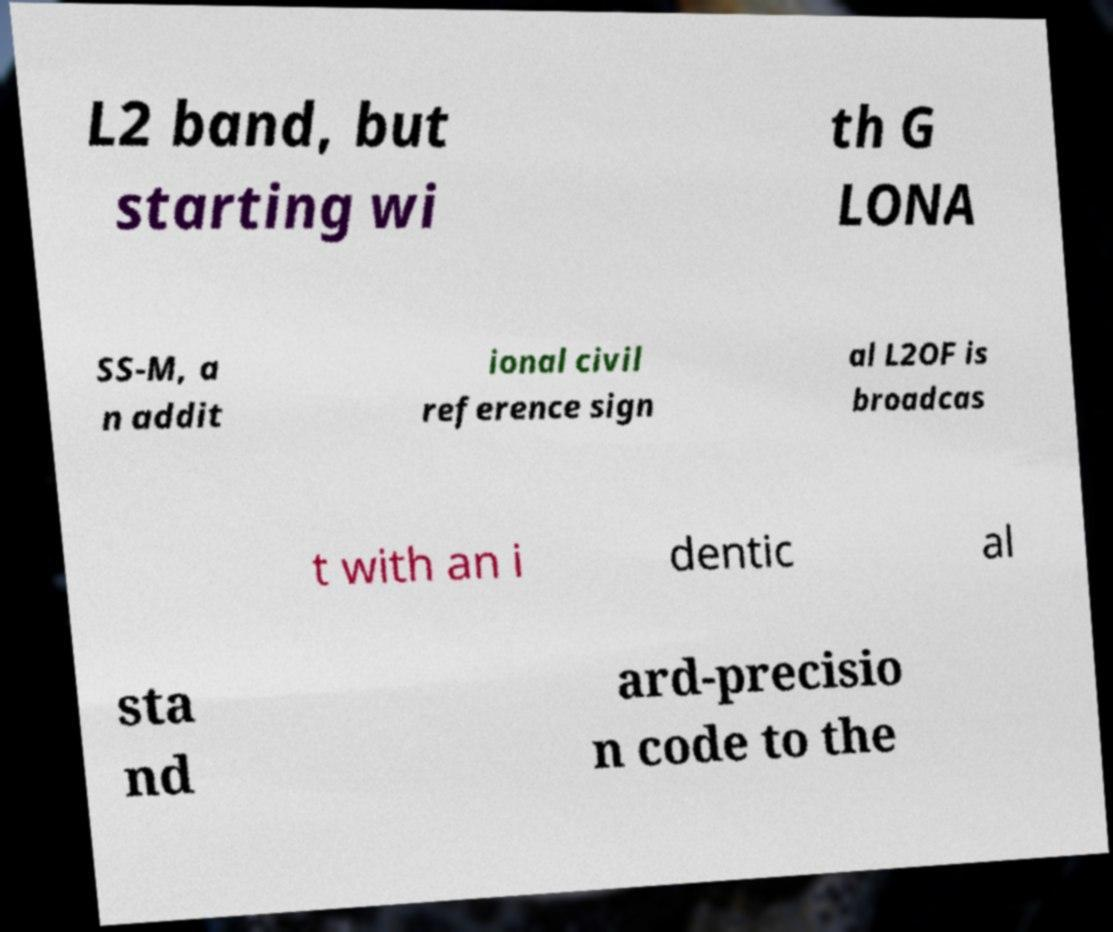What messages or text are displayed in this image? I need them in a readable, typed format. L2 band, but starting wi th G LONA SS-M, a n addit ional civil reference sign al L2OF is broadcas t with an i dentic al sta nd ard-precisio n code to the 